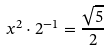<formula> <loc_0><loc_0><loc_500><loc_500>x ^ { 2 } \cdot 2 ^ { - 1 } = \frac { \sqrt { 5 } } { 2 }</formula> 